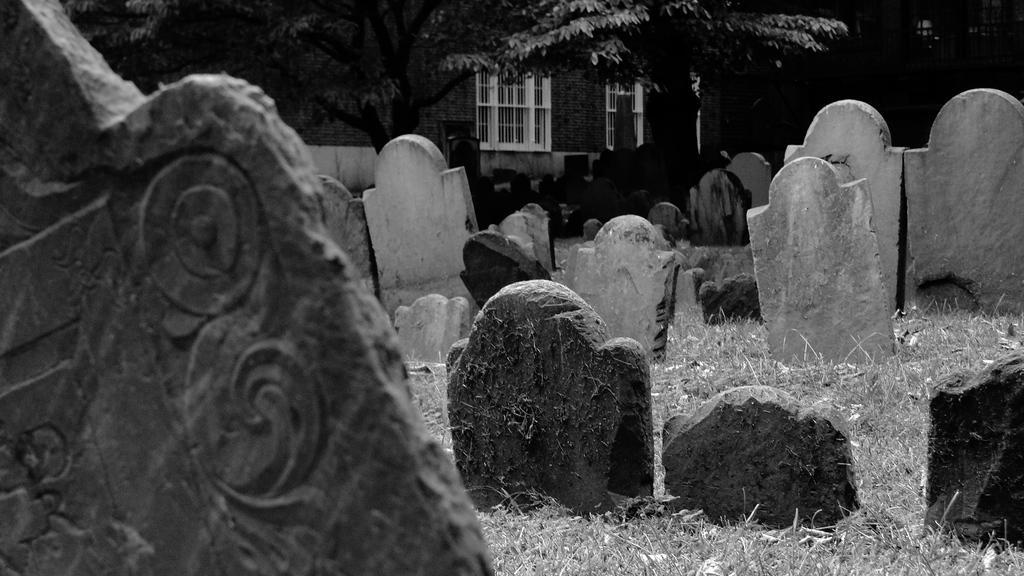Please provide a concise description of this image. I see this is a black and white image and I see number of tombstones and I see the grass. In the background I see the trees and the building over here and I see the windows and I see that it is dark over here. 